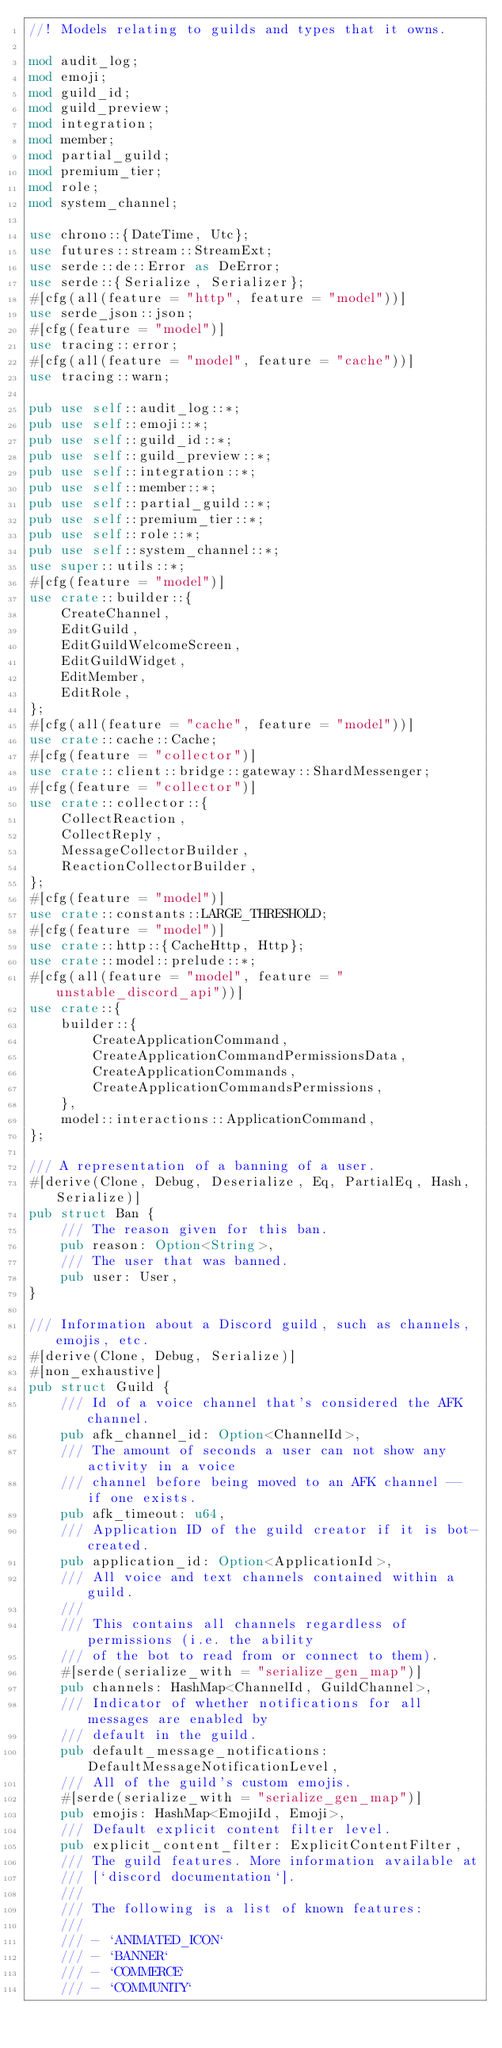<code> <loc_0><loc_0><loc_500><loc_500><_Rust_>//! Models relating to guilds and types that it owns.

mod audit_log;
mod emoji;
mod guild_id;
mod guild_preview;
mod integration;
mod member;
mod partial_guild;
mod premium_tier;
mod role;
mod system_channel;

use chrono::{DateTime, Utc};
use futures::stream::StreamExt;
use serde::de::Error as DeError;
use serde::{Serialize, Serializer};
#[cfg(all(feature = "http", feature = "model"))]
use serde_json::json;
#[cfg(feature = "model")]
use tracing::error;
#[cfg(all(feature = "model", feature = "cache"))]
use tracing::warn;

pub use self::audit_log::*;
pub use self::emoji::*;
pub use self::guild_id::*;
pub use self::guild_preview::*;
pub use self::integration::*;
pub use self::member::*;
pub use self::partial_guild::*;
pub use self::premium_tier::*;
pub use self::role::*;
pub use self::system_channel::*;
use super::utils::*;
#[cfg(feature = "model")]
use crate::builder::{
    CreateChannel,
    EditGuild,
    EditGuildWelcomeScreen,
    EditGuildWidget,
    EditMember,
    EditRole,
};
#[cfg(all(feature = "cache", feature = "model"))]
use crate::cache::Cache;
#[cfg(feature = "collector")]
use crate::client::bridge::gateway::ShardMessenger;
#[cfg(feature = "collector")]
use crate::collector::{
    CollectReaction,
    CollectReply,
    MessageCollectorBuilder,
    ReactionCollectorBuilder,
};
#[cfg(feature = "model")]
use crate::constants::LARGE_THRESHOLD;
#[cfg(feature = "model")]
use crate::http::{CacheHttp, Http};
use crate::model::prelude::*;
#[cfg(all(feature = "model", feature = "unstable_discord_api"))]
use crate::{
    builder::{
        CreateApplicationCommand,
        CreateApplicationCommandPermissionsData,
        CreateApplicationCommands,
        CreateApplicationCommandsPermissions,
    },
    model::interactions::ApplicationCommand,
};

/// A representation of a banning of a user.
#[derive(Clone, Debug, Deserialize, Eq, PartialEq, Hash, Serialize)]
pub struct Ban {
    /// The reason given for this ban.
    pub reason: Option<String>,
    /// The user that was banned.
    pub user: User,
}

/// Information about a Discord guild, such as channels, emojis, etc.
#[derive(Clone, Debug, Serialize)]
#[non_exhaustive]
pub struct Guild {
    /// Id of a voice channel that's considered the AFK channel.
    pub afk_channel_id: Option<ChannelId>,
    /// The amount of seconds a user can not show any activity in a voice
    /// channel before being moved to an AFK channel -- if one exists.
    pub afk_timeout: u64,
    /// Application ID of the guild creator if it is bot-created.
    pub application_id: Option<ApplicationId>,
    /// All voice and text channels contained within a guild.
    ///
    /// This contains all channels regardless of permissions (i.e. the ability
    /// of the bot to read from or connect to them).
    #[serde(serialize_with = "serialize_gen_map")]
    pub channels: HashMap<ChannelId, GuildChannel>,
    /// Indicator of whether notifications for all messages are enabled by
    /// default in the guild.
    pub default_message_notifications: DefaultMessageNotificationLevel,
    /// All of the guild's custom emojis.
    #[serde(serialize_with = "serialize_gen_map")]
    pub emojis: HashMap<EmojiId, Emoji>,
    /// Default explicit content filter level.
    pub explicit_content_filter: ExplicitContentFilter,
    /// The guild features. More information available at
    /// [`discord documentation`].
    ///
    /// The following is a list of known features:
    ///
    /// - `ANIMATED_ICON`
    /// - `BANNER`
    /// - `COMMERCE`
    /// - `COMMUNITY`</code> 